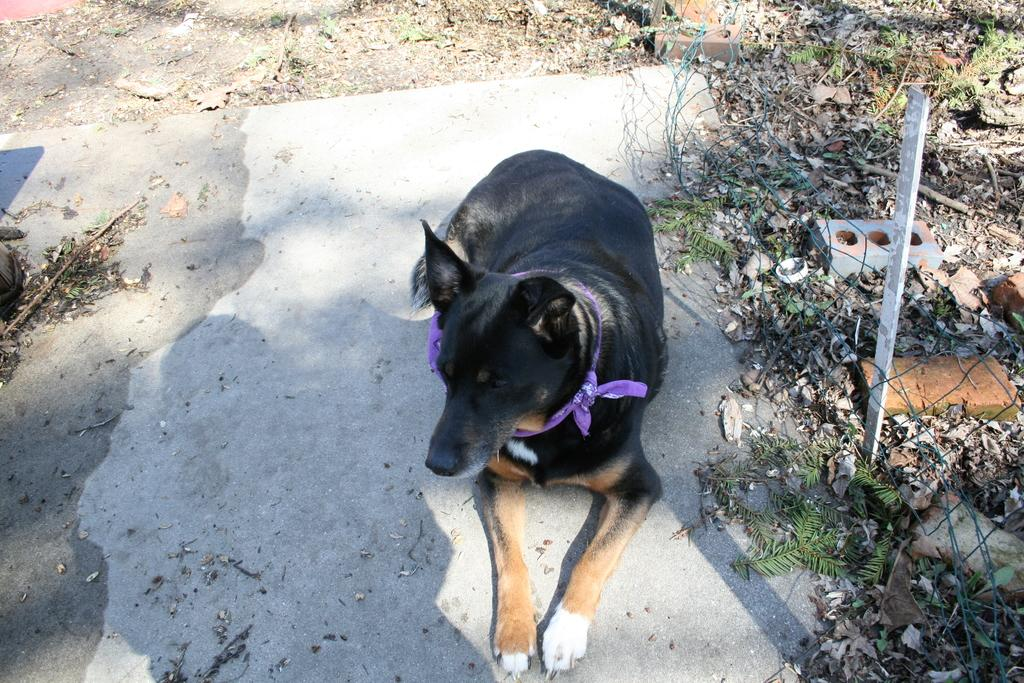What type of creature is in the picture? There is an animal in the picture. Can you describe the position of the animal in the image? The animal is sitting on a surface. What can be seen on the right side of the image? There is a metal grill fence on the right side of the image. What type of writing can be seen on the animal's back in the image? There is no writing visible on the animal's back in the image. 